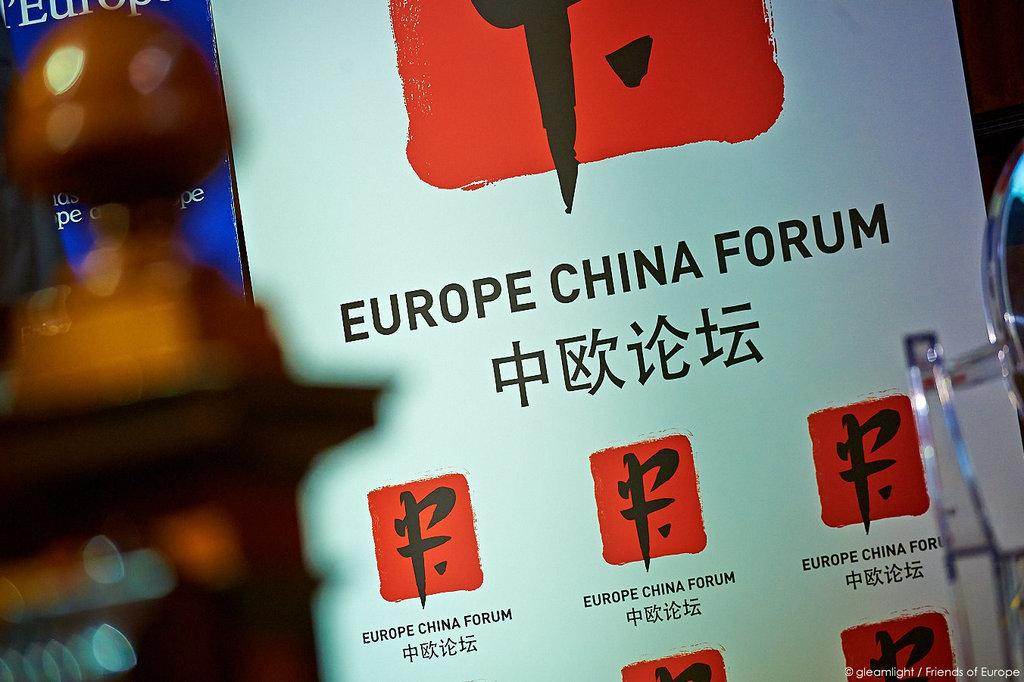<image>
Relay a brief, clear account of the picture shown. A big poster that says Europe China Forum. 